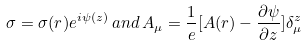Convert formula to latex. <formula><loc_0><loc_0><loc_500><loc_500>\sigma = \sigma ( r ) e ^ { i \psi ( z ) } \, a n d \, A _ { \mu } = \frac { 1 } { e } [ A ( r ) - \frac { \partial { \psi } } { \partial z } ] \delta ^ { z } _ { \mu }</formula> 